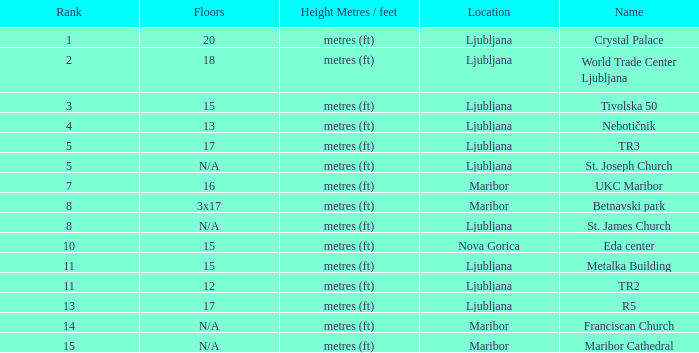Which Floors have a Location of ljubljana, and a Name of tr3? 17.0. 